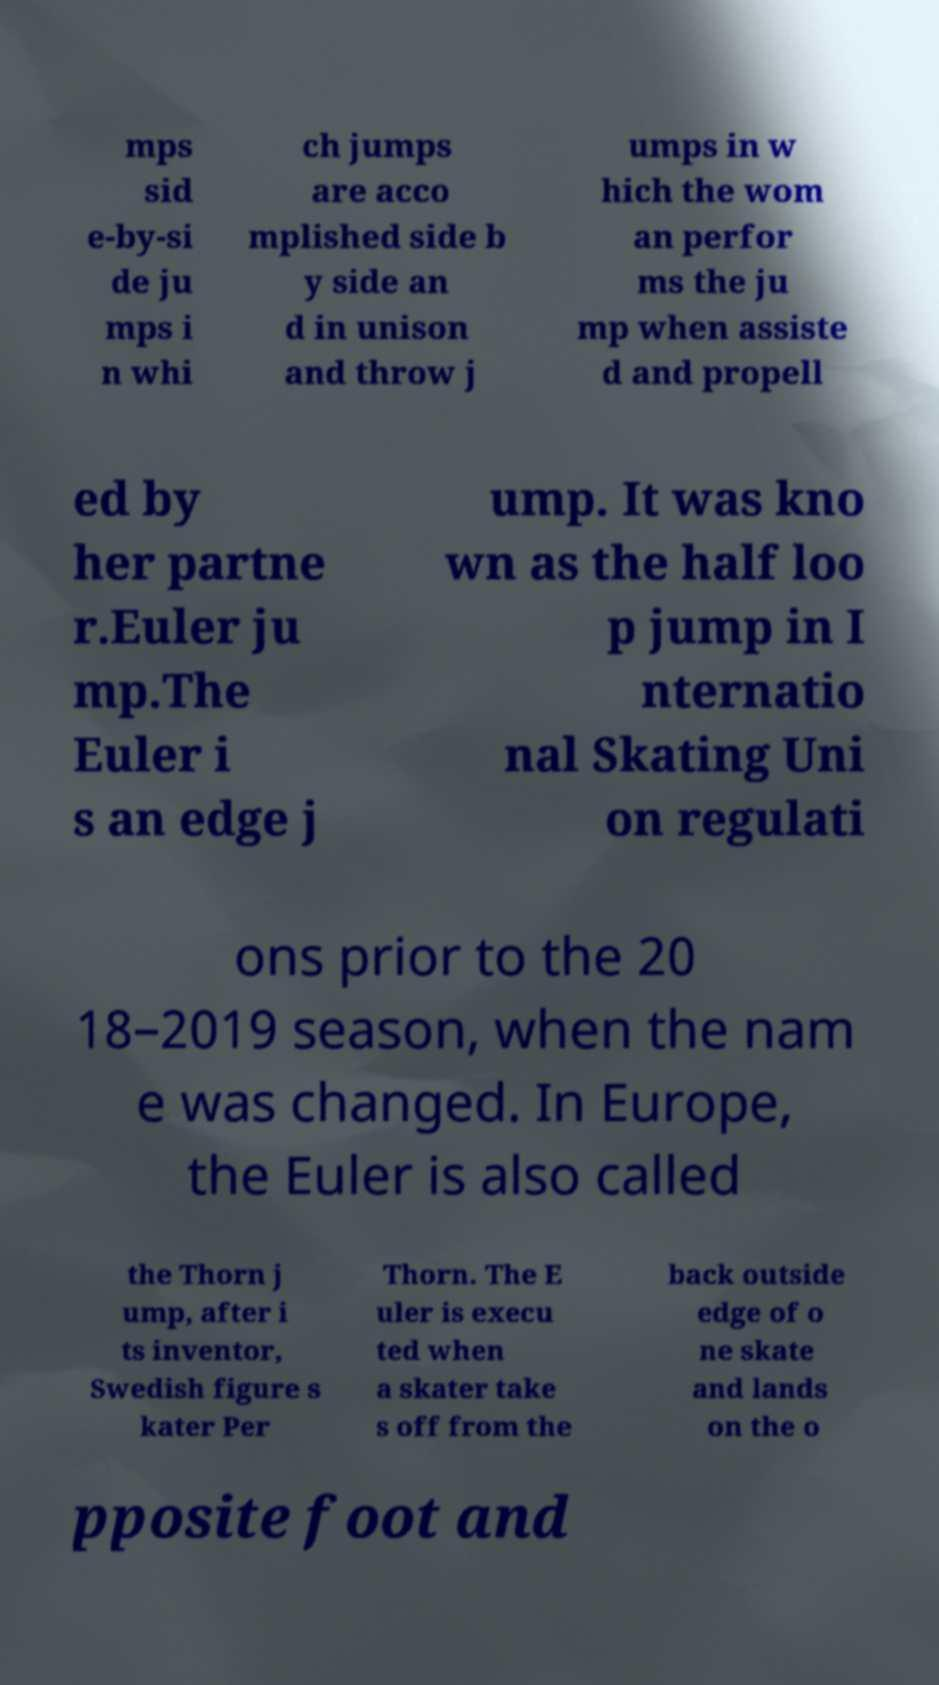Please read and relay the text visible in this image. What does it say? mps sid e-by-si de ju mps i n whi ch jumps are acco mplished side b y side an d in unison and throw j umps in w hich the wom an perfor ms the ju mp when assiste d and propell ed by her partne r.Euler ju mp.The Euler i s an edge j ump. It was kno wn as the half loo p jump in I nternatio nal Skating Uni on regulati ons prior to the 20 18–2019 season, when the nam e was changed. In Europe, the Euler is also called the Thorn j ump, after i ts inventor, Swedish figure s kater Per Thorn. The E uler is execu ted when a skater take s off from the back outside edge of o ne skate and lands on the o pposite foot and 